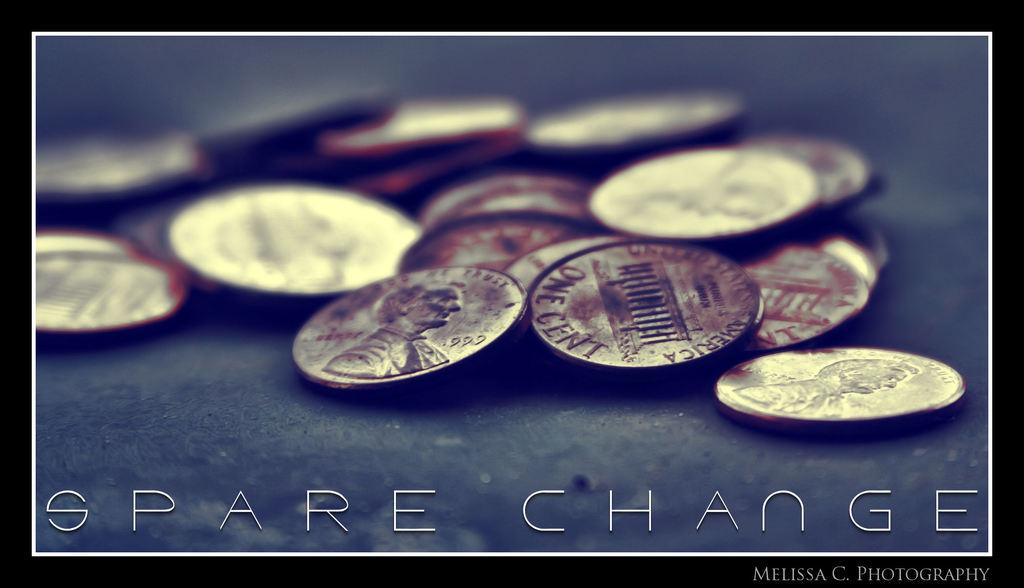Provide a one-sentence caption for the provided image. a picture of pennies and the words "Spare Change". 